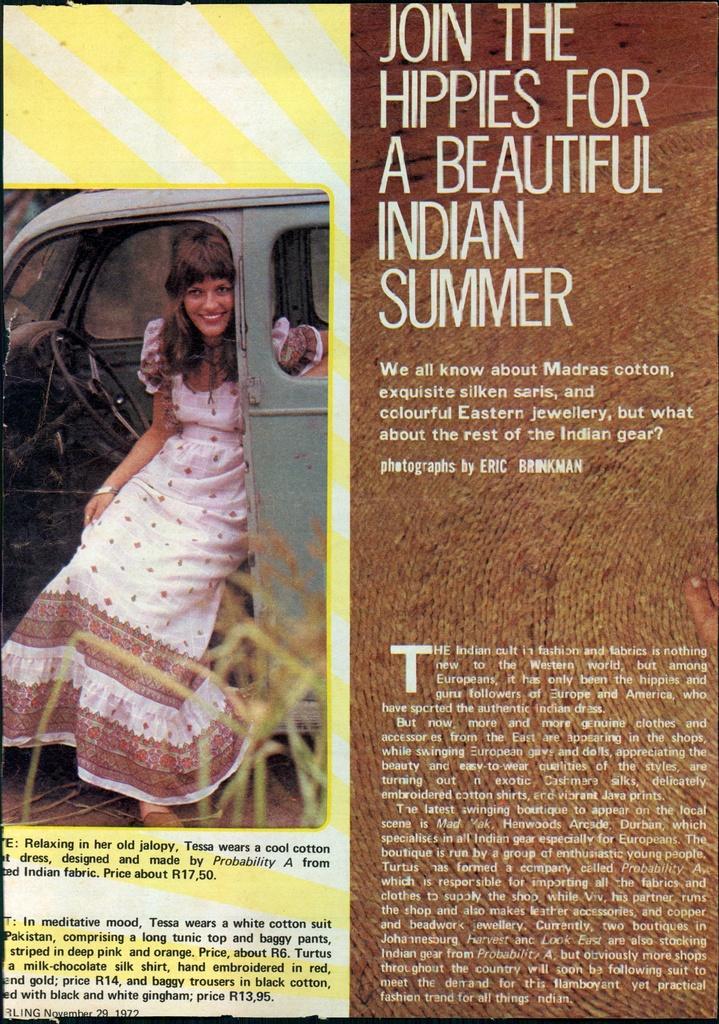Please provide a concise description of this image. This image consists of a poster. On the left side I can see an image of a woman who is sitting inside the car and smiling. On the right side, I can see some text. 